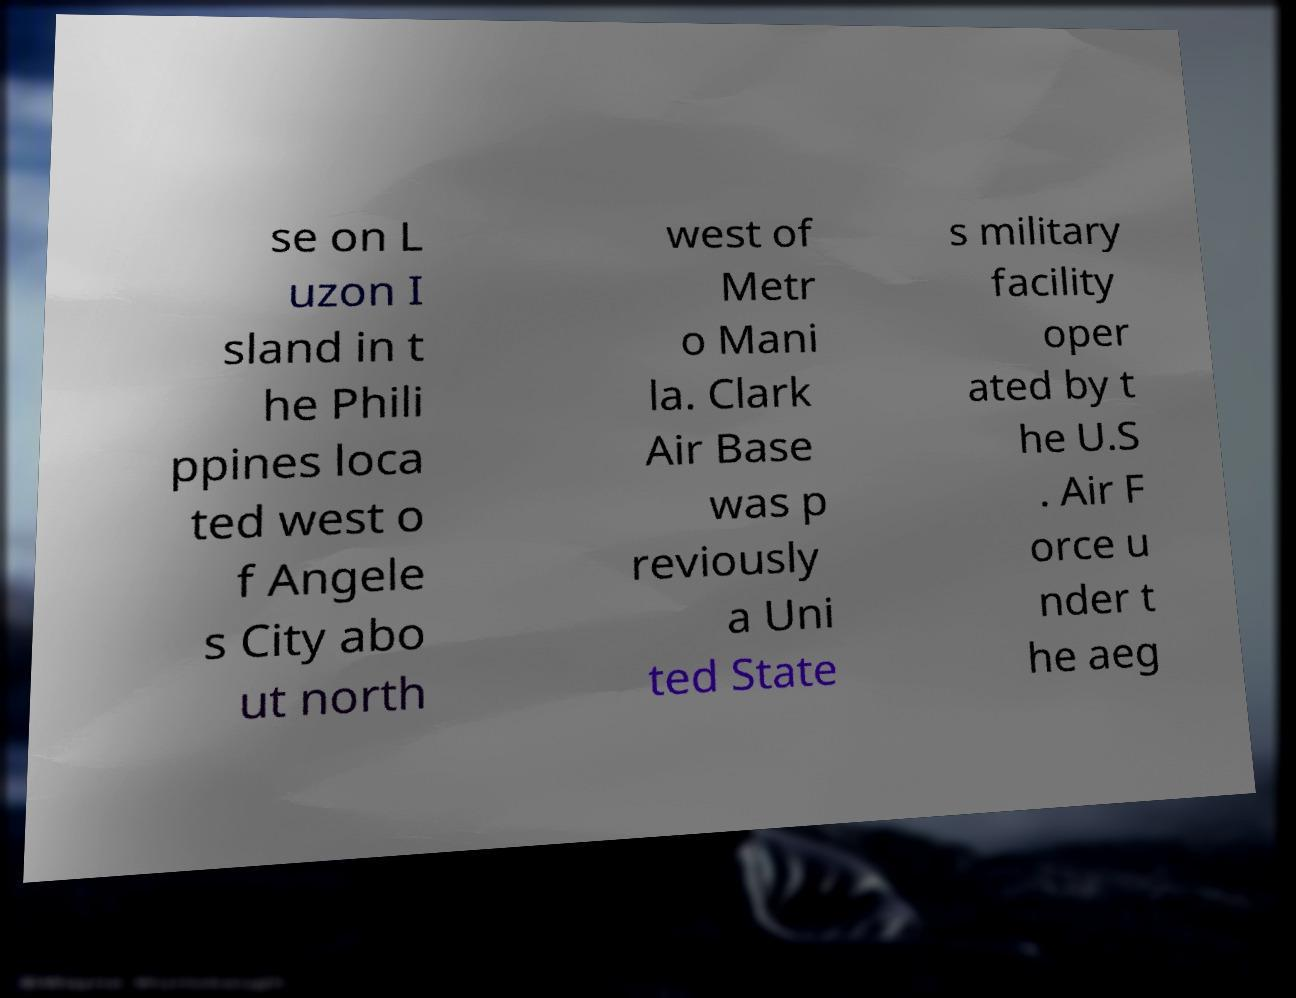Could you extract and type out the text from this image? se on L uzon I sland in t he Phili ppines loca ted west o f Angele s City abo ut north west of Metr o Mani la. Clark Air Base was p reviously a Uni ted State s military facility oper ated by t he U.S . Air F orce u nder t he aeg 